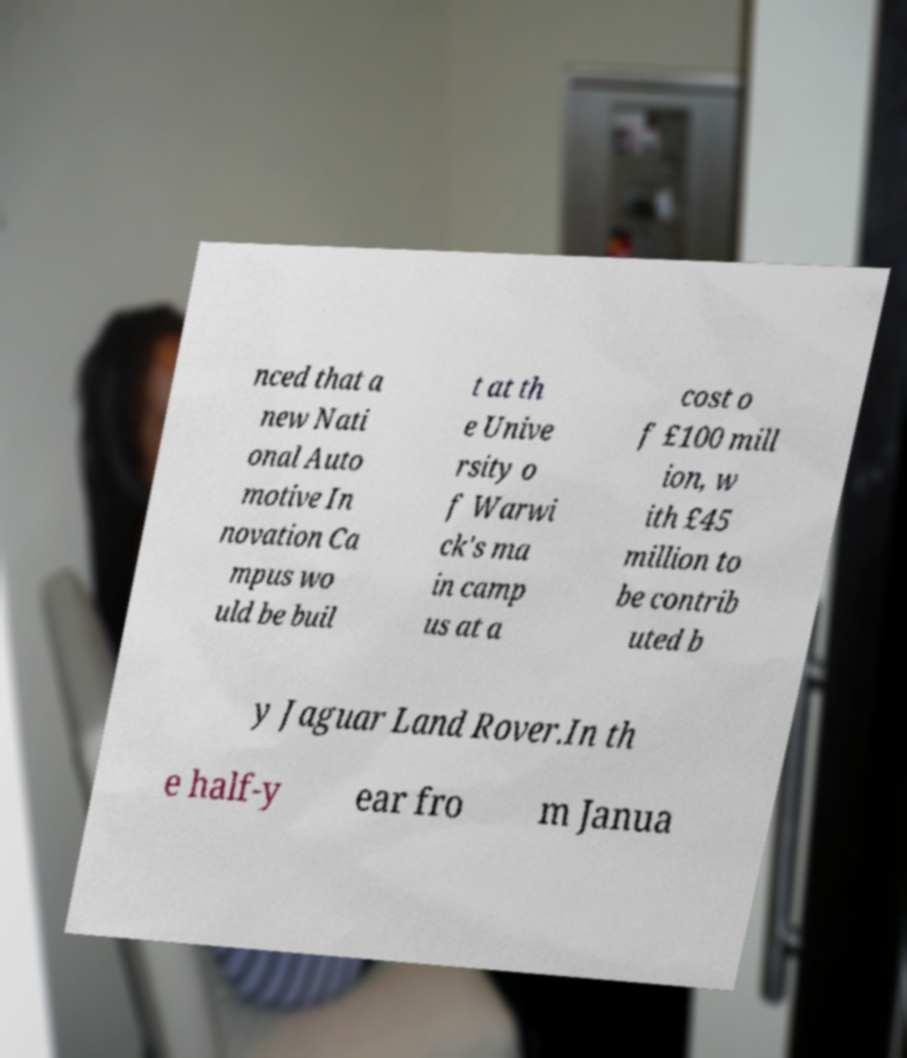I need the written content from this picture converted into text. Can you do that? nced that a new Nati onal Auto motive In novation Ca mpus wo uld be buil t at th e Unive rsity o f Warwi ck's ma in camp us at a cost o f £100 mill ion, w ith £45 million to be contrib uted b y Jaguar Land Rover.In th e half-y ear fro m Janua 